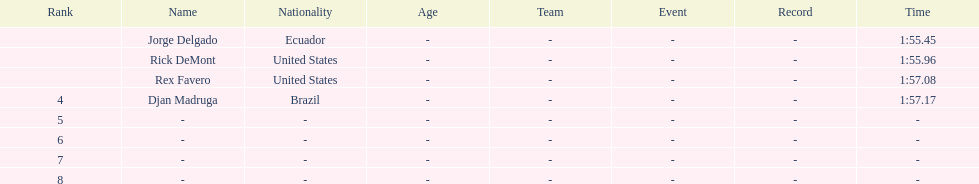Would you be able to parse every entry in this table? {'header': ['Rank', 'Name', 'Nationality', 'Age', 'Team', 'Event', 'Record', 'Time'], 'rows': [['', 'Jorge Delgado', 'Ecuador', '-', '-', '-', '-', '1:55.45'], ['', 'Rick DeMont', 'United States', '-', '-', '-', '-', '1:55.96'], ['', 'Rex Favero', 'United States', '-', '-', '-', '-', '1:57.08'], ['4', 'Djan Madruga', 'Brazil', '-', '-', '-', '-', '1:57.17'], ['5', '-', '-', '-', '-', '-', '-', '-'], ['6', '-', '-', '-', '-', '-', '-', '-'], ['7', '-', '-', '-', '-', '-', '-', '-'], ['8', '-', '-', '-', '-', '-', '-', '-']]} How many ranked swimmers were from the united states? 2. 